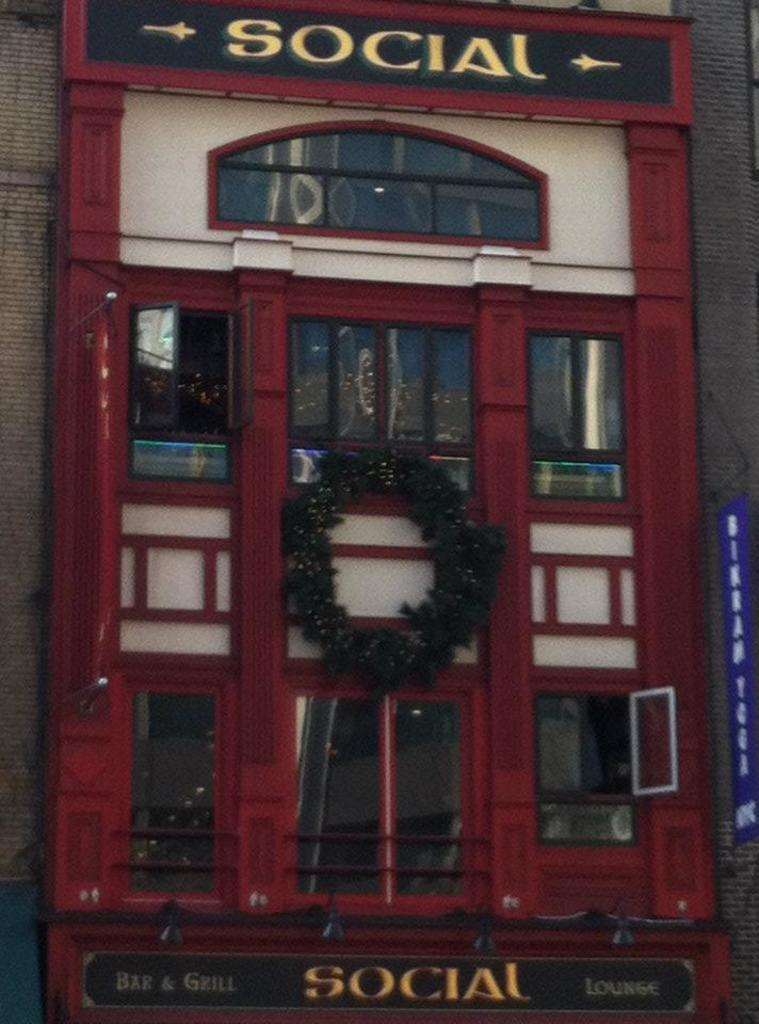What is the main structure in the image? There is a building in the image. What can be seen on the building? There is writing on the building. What feature of the building is mentioned in the facts? The building has windows. What type of skate is being used by the representative in the image? There is no skate or representative present in the image. 